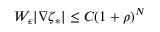Convert formula to latex. <formula><loc_0><loc_0><loc_500><loc_500>W _ { \epsilon } | \nabla \zeta _ { * } | \leq C ( 1 + \rho ) ^ { N }</formula> 